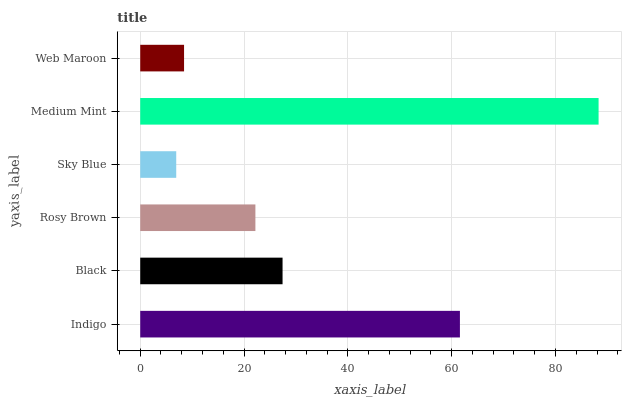Is Sky Blue the minimum?
Answer yes or no. Yes. Is Medium Mint the maximum?
Answer yes or no. Yes. Is Black the minimum?
Answer yes or no. No. Is Black the maximum?
Answer yes or no. No. Is Indigo greater than Black?
Answer yes or no. Yes. Is Black less than Indigo?
Answer yes or no. Yes. Is Black greater than Indigo?
Answer yes or no. No. Is Indigo less than Black?
Answer yes or no. No. Is Black the high median?
Answer yes or no. Yes. Is Rosy Brown the low median?
Answer yes or no. Yes. Is Sky Blue the high median?
Answer yes or no. No. Is Medium Mint the low median?
Answer yes or no. No. 